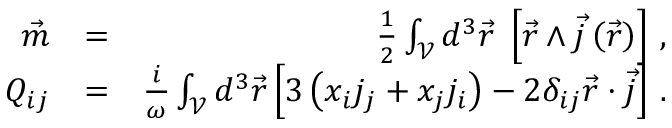Convert formula to latex. <formula><loc_0><loc_0><loc_500><loc_500>\begin{array} { r l r } { \vec { m } } & { = } & { \frac { 1 } { 2 } \int _ { \mathcal { V } } d ^ { 3 } \vec { r } \, \left [ \vec { r } \wedge \vec { j } \left ( \vec { r } \right ) \right ] \, , } \\ { Q _ { i j } } & { = } & { \frac { i } { \omega } \int _ { \mathcal { V } } d ^ { 3 } \vec { r } \left [ 3 \left ( x _ { i } j _ { j } + x _ { j } j _ { i } \right ) - 2 \delta _ { i j } \vec { r } \cdot \vec { j } \right ] \, . } \end{array}</formula> 